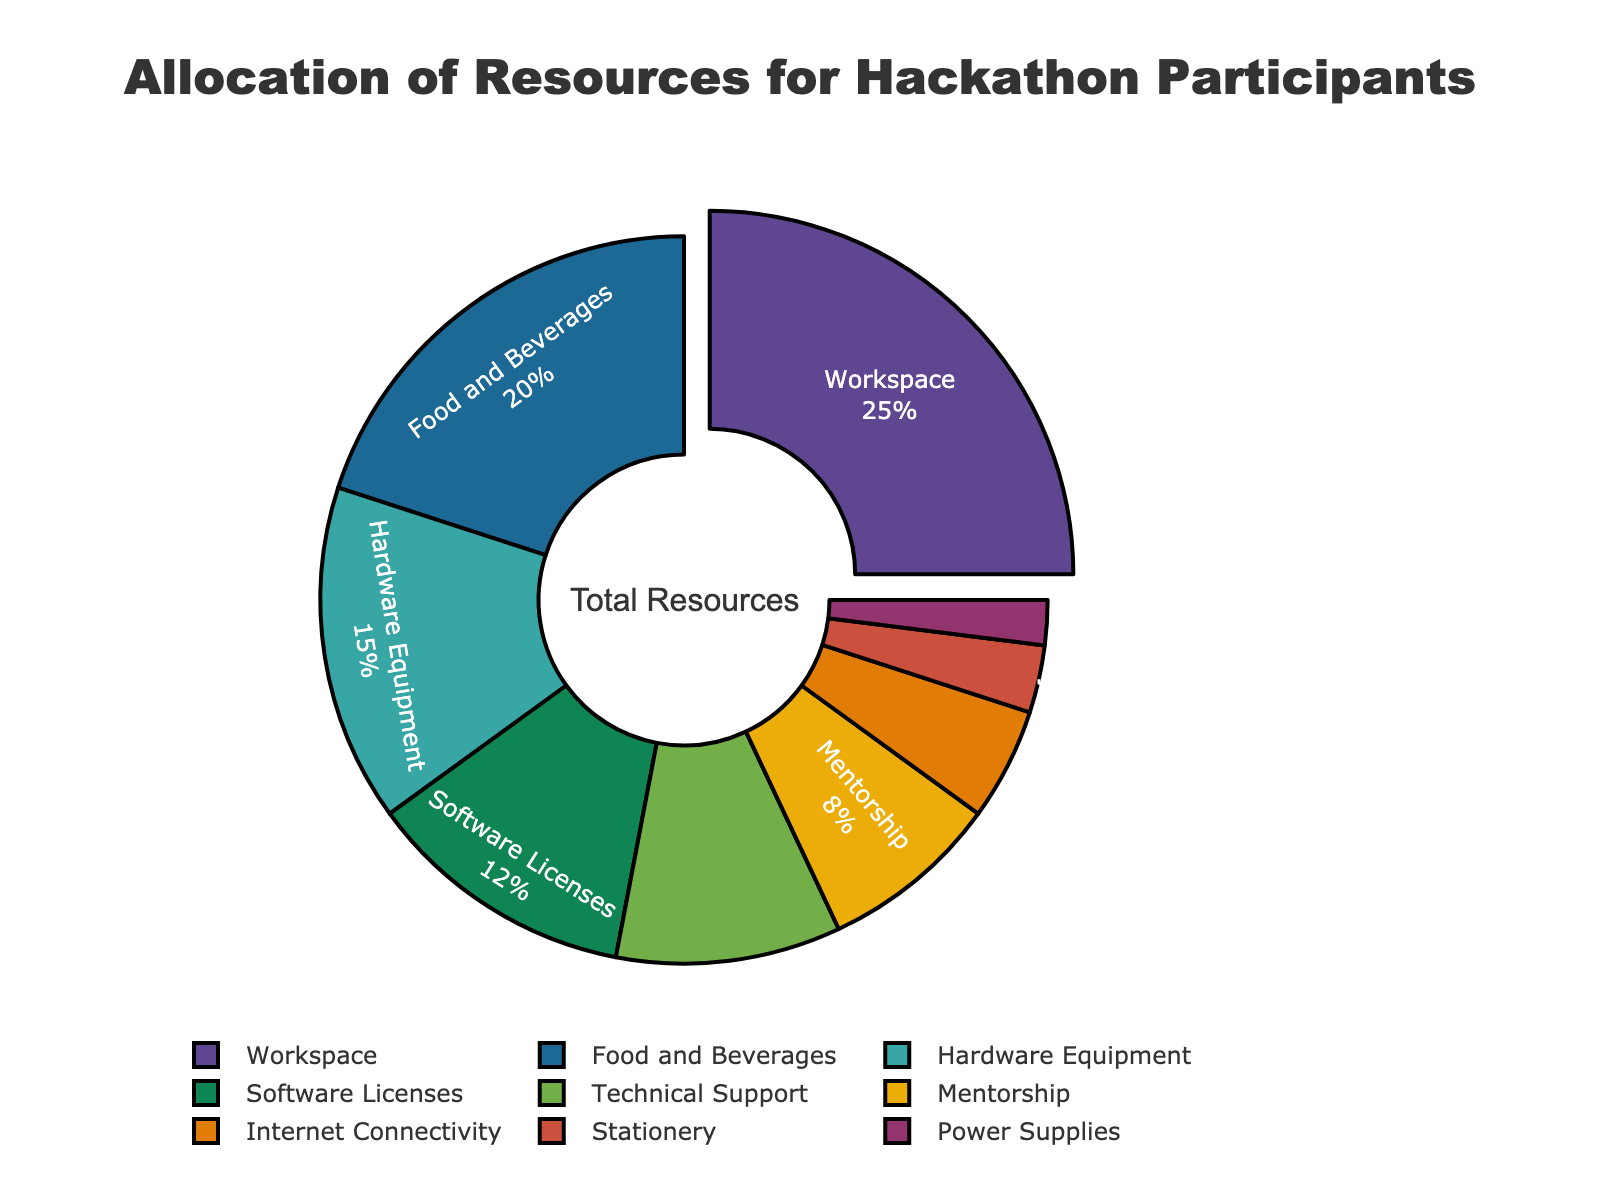What's the percentage allocation for Food and Beverages? Locate the "Food and Beverages" segment in the pie chart and read the percentage label associated with it.
Answer: 20% Which resource has the largest allocation? Identify the segment that is pulled out from the pie chart, as it visually highlights the largest allocation. This segment is labeled "Workspace".
Answer: Workspace What is the combined percentage allocation for Internet Connectivity and Stationery? Locate the "Internet Connectivity" and "Stationery" segments in the pie chart. Their percentages are 5% and 3%, respectively. Add these percentages together: 5% + 3% = 8%.
Answer: 8% Which resource has a smaller allocation: Mentorship or Technical Support? Compare the "Mentorship" and "Technical Support" segments. The pie chart shows Mentorship at 8% and Technical Support at 10%.
Answer: Mentorship What is the total percentage allocated to Hardware Equipment, Software Licenses, and Power Supplies? Locate the segments for "Hardware Equipment" (15%), "Software Licenses" (12%), and "Power Supplies" (2%) in the pie chart. Add these percentages together: 15% + 12% + 2% = 29%.
Answer: 29% How much more is allocated to Food and Beverages compared to Internet Connectivity? Identify the segments for "Food and Beverages" (20%) and "Internet Connectivity" (5%) in the pie chart. Subtract the percentage for Internet Connectivity from the percentage for Food and Beverages: 20% - 5% = 15%.
Answer: 15% What is the average percentage allocation of Software Licenses, Technical Support, and Mentorship? Locate the segments for "Software Licenses" (12%), "Technical Support" (10%), and "Mentorship" (8%) in the pie chart. Add these percentages together and then divide by the number of items: (12% + 10% + 8%) / 3 = 10%.
Answer: 10% Which resource has a higher allocation: Hardware Equipment or Software Licenses? Compare the "Hardware Equipment" (15%) and "Software Licenses" (12%) segments in the pie chart.
Answer: Hardware Equipment What is the combined percentage allocation for the top three resources? Identify the segments of the top three resources: "Workspace" (25%), "Food and Beverages" (20%), and "Hardware Equipment" (15%). Add these percentages together: 25% + 20% + 15% = 60%.
Answer: 60% 